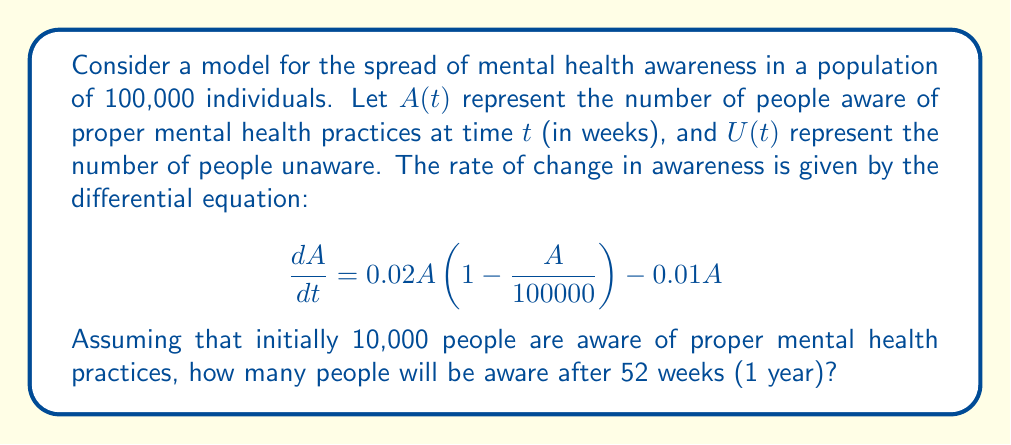Help me with this question. To solve this problem, we need to use the logistic growth model with a decay term. Let's break it down step-by-step:

1) The given differential equation is:

   $$\frac{dA}{dt} = 0.02A\left(1-\frac{A}{100000}\right) - 0.01A$$

2) This is a logistic growth model with a carrying capacity of 100,000 (the total population) and a decay term (-0.01A).

3) To solve this equation, we can use separation of variables:

   $$\frac{dA}{A(0.01-0.0000002A)} = dt$$

4) Integrating both sides:

   $$-50000\ln|0.01-0.0000002A| = t + C$$

5) Using the initial condition A(0) = 10,000, we can solve for C:

   $$C = -50000\ln|0.01-0.0000002(10000)| = -50000\ln(0.008) \approx 241889.65$$

6) Now we have the solution:

   $$-50000\ln|0.01-0.0000002A| = t + 241889.65$$

7) To find A after 52 weeks, we substitute t = 52:

   $$-50000\ln|0.01-0.0000002A| = 52 + 241889.65 = 241941.65$$

8) Solving for A:

   $$\ln|0.01-0.0000002A| = -4.83883$$
   $$0.01-0.0000002A = e^{-4.83883} \approx 0.00790807$$
   $$-0.0000002A = -0.00209193$$
   $$A \approx 10459.65$$

9) Rounding to the nearest whole number, as we're dealing with people:

   $$A(52) \approx 10460$$

This result shows that after 52 weeks, approximately 10,460 people will be aware of proper mental health practices.
Answer: After 52 weeks, approximately 10,460 people will be aware of proper mental health practices. 